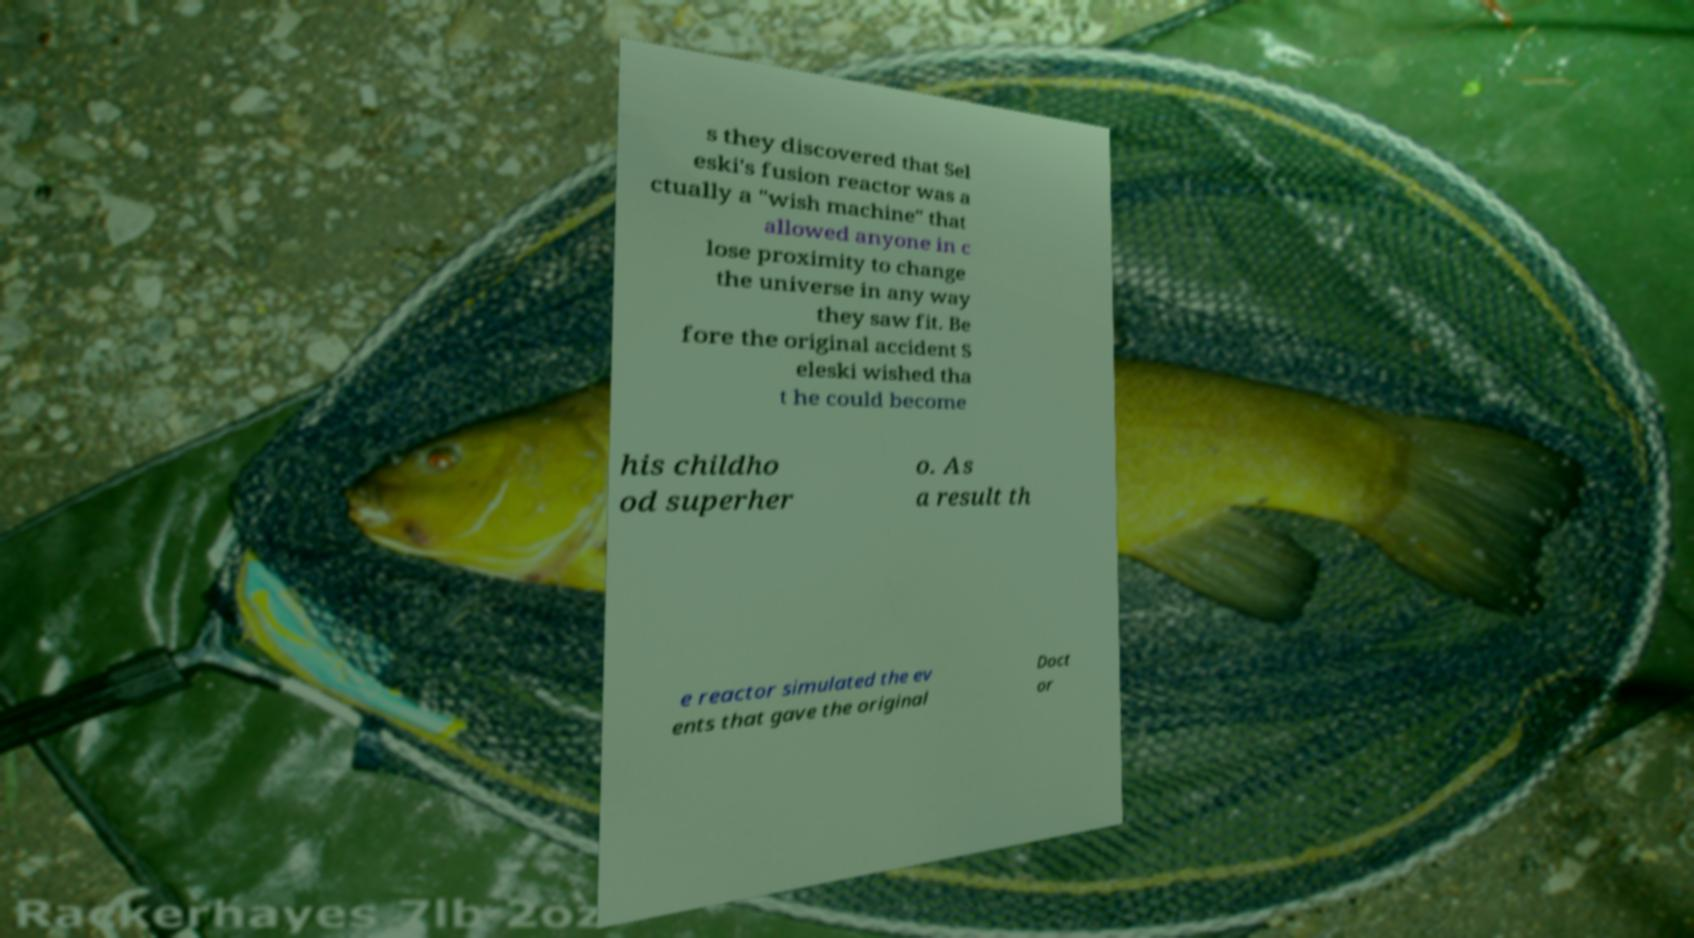Can you read and provide the text displayed in the image?This photo seems to have some interesting text. Can you extract and type it out for me? s they discovered that Sel eski's fusion reactor was a ctually a "wish machine" that allowed anyone in c lose proximity to change the universe in any way they saw fit. Be fore the original accident S eleski wished tha t he could become his childho od superher o. As a result th e reactor simulated the ev ents that gave the original Doct or 